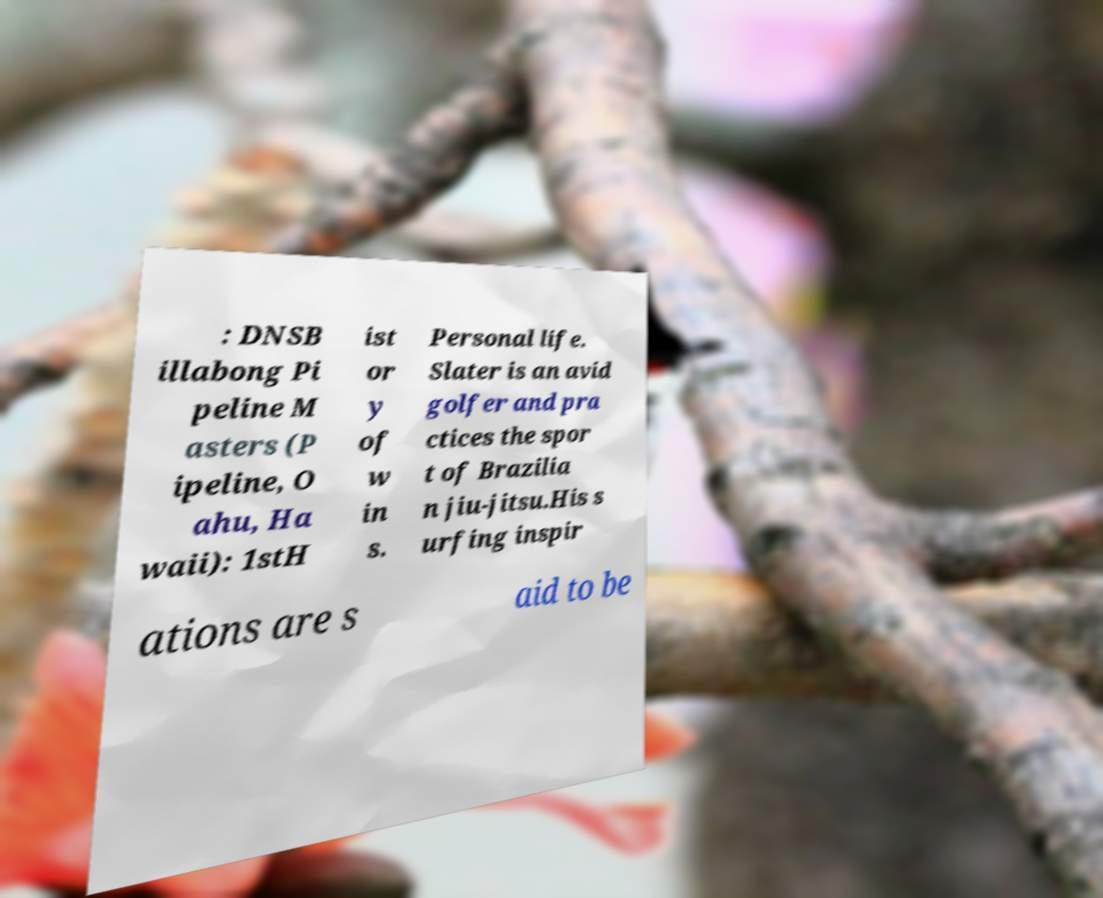There's text embedded in this image that I need extracted. Can you transcribe it verbatim? : DNSB illabong Pi peline M asters (P ipeline, O ahu, Ha waii): 1stH ist or y of w in s. Personal life. Slater is an avid golfer and pra ctices the spor t of Brazilia n jiu-jitsu.His s urfing inspir ations are s aid to be 